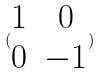<formula> <loc_0><loc_0><loc_500><loc_500>( \begin{matrix} 1 & 0 \\ 0 & - 1 \end{matrix} )</formula> 